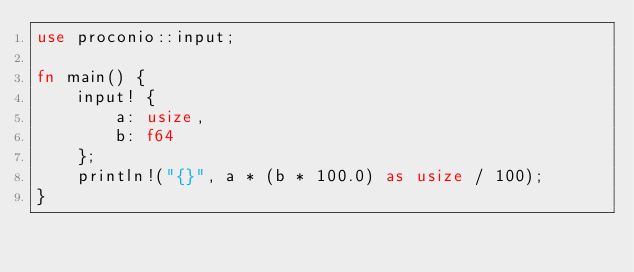<code> <loc_0><loc_0><loc_500><loc_500><_Rust_>use proconio::input;

fn main() {
    input! {
        a: usize,
        b: f64
    };
    println!("{}", a * (b * 100.0) as usize / 100);
}
</code> 